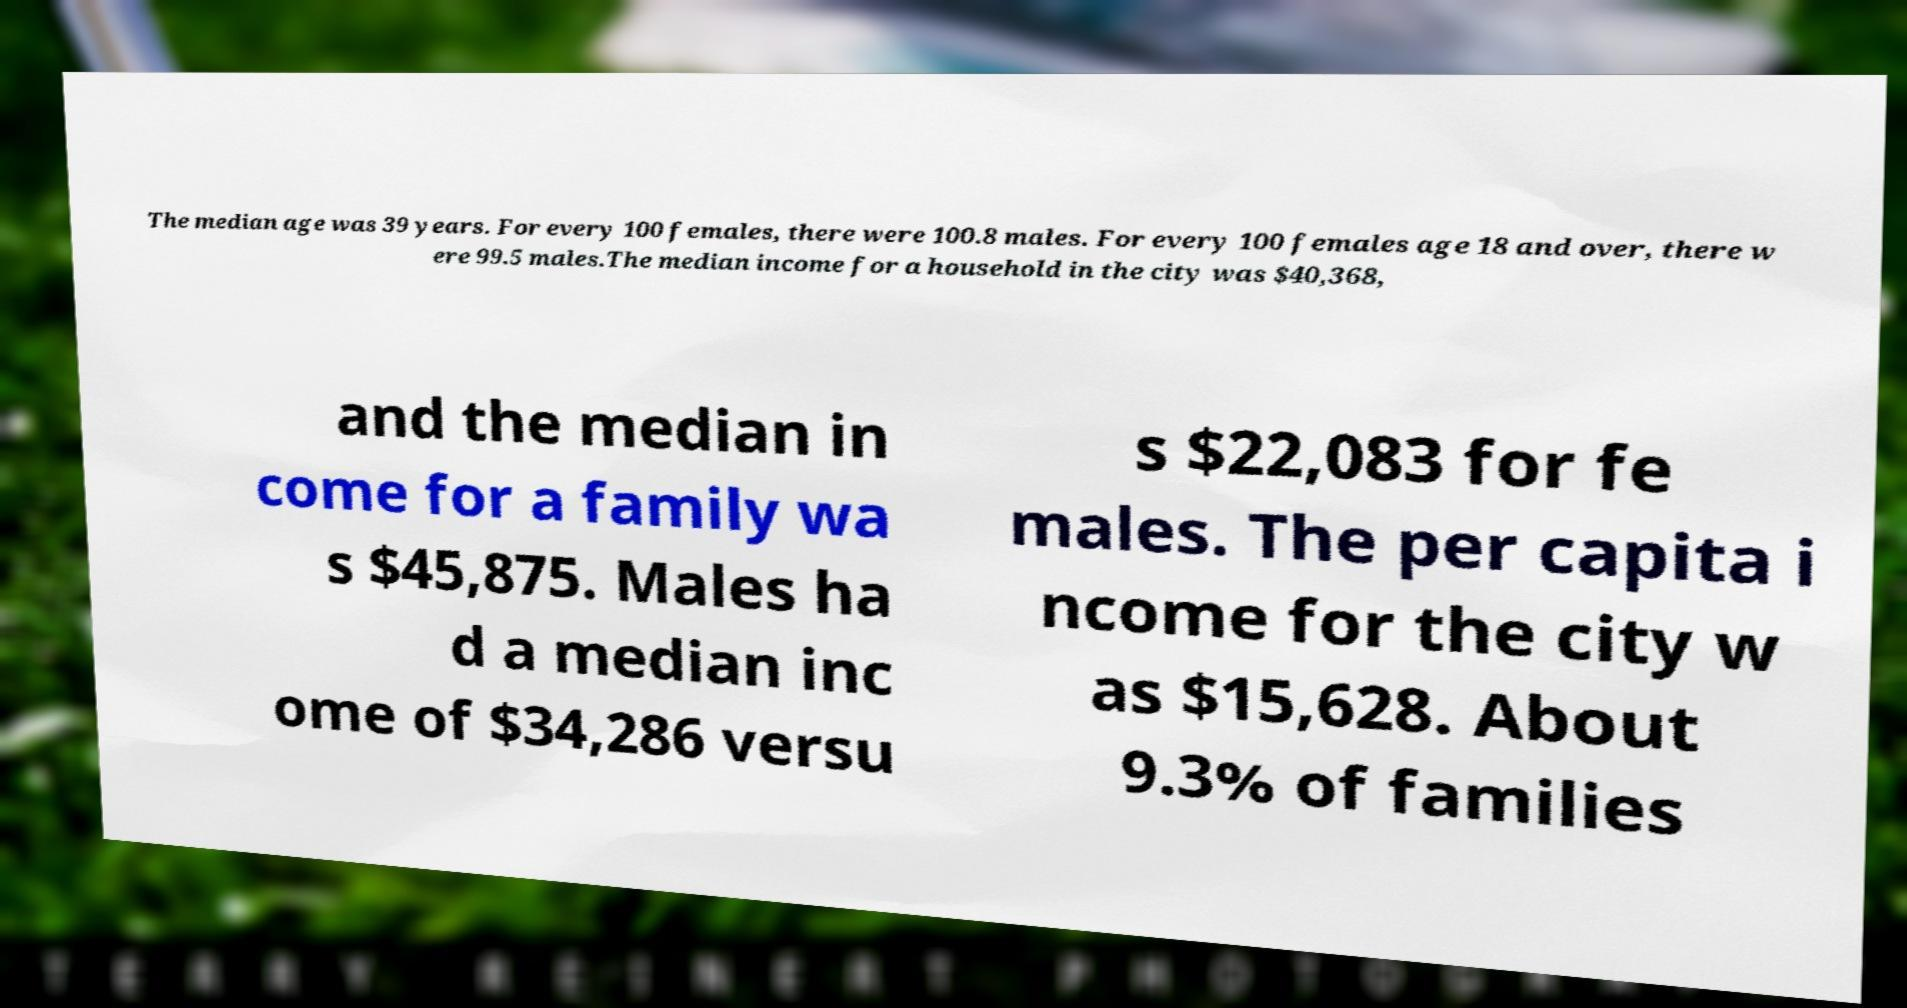Please read and relay the text visible in this image. What does it say? The median age was 39 years. For every 100 females, there were 100.8 males. For every 100 females age 18 and over, there w ere 99.5 males.The median income for a household in the city was $40,368, and the median in come for a family wa s $45,875. Males ha d a median inc ome of $34,286 versu s $22,083 for fe males. The per capita i ncome for the city w as $15,628. About 9.3% of families 